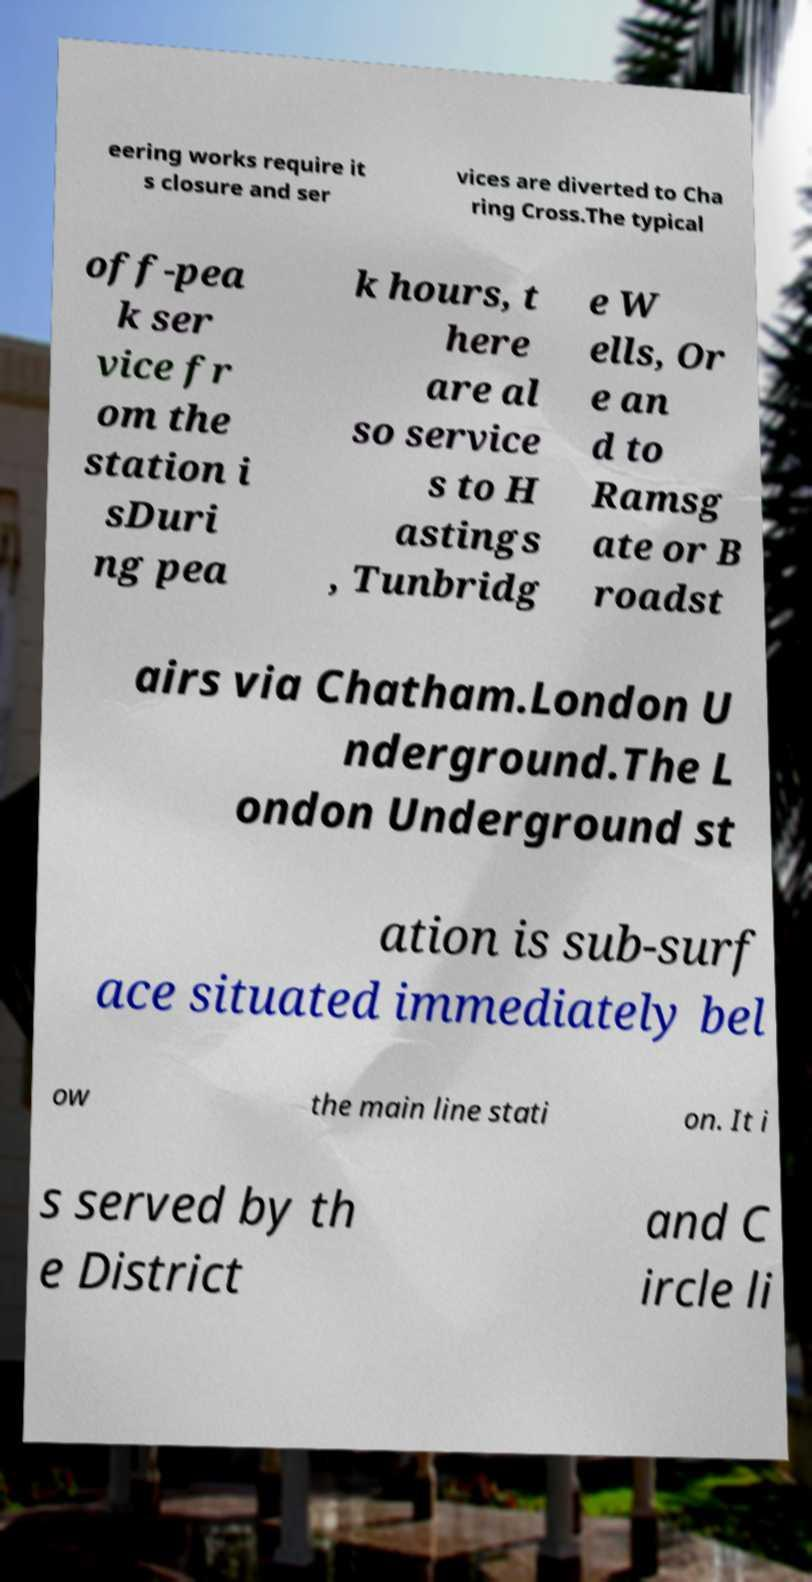I need the written content from this picture converted into text. Can you do that? eering works require it s closure and ser vices are diverted to Cha ring Cross.The typical off-pea k ser vice fr om the station i sDuri ng pea k hours, t here are al so service s to H astings , Tunbridg e W ells, Or e an d to Ramsg ate or B roadst airs via Chatham.London U nderground.The L ondon Underground st ation is sub-surf ace situated immediately bel ow the main line stati on. It i s served by th e District and C ircle li 